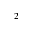<formula> <loc_0><loc_0><loc_500><loc_500>^ { 2 }</formula> 